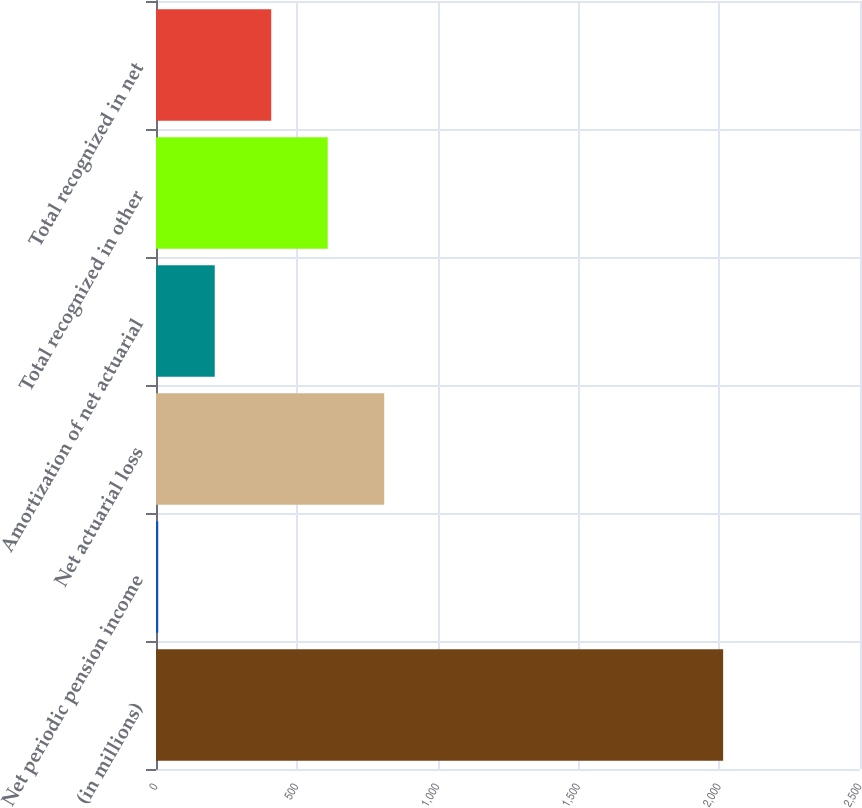<chart> <loc_0><loc_0><loc_500><loc_500><bar_chart><fcel>(in millions)<fcel>Net periodic pension income<fcel>Net actuarial loss<fcel>Amortization of net actuarial<fcel>Total recognized in other<fcel>Total recognized in net<nl><fcel>2014<fcel>8<fcel>810.4<fcel>208.6<fcel>609.8<fcel>409.2<nl></chart> 